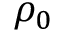<formula> <loc_0><loc_0><loc_500><loc_500>\rho _ { 0 }</formula> 